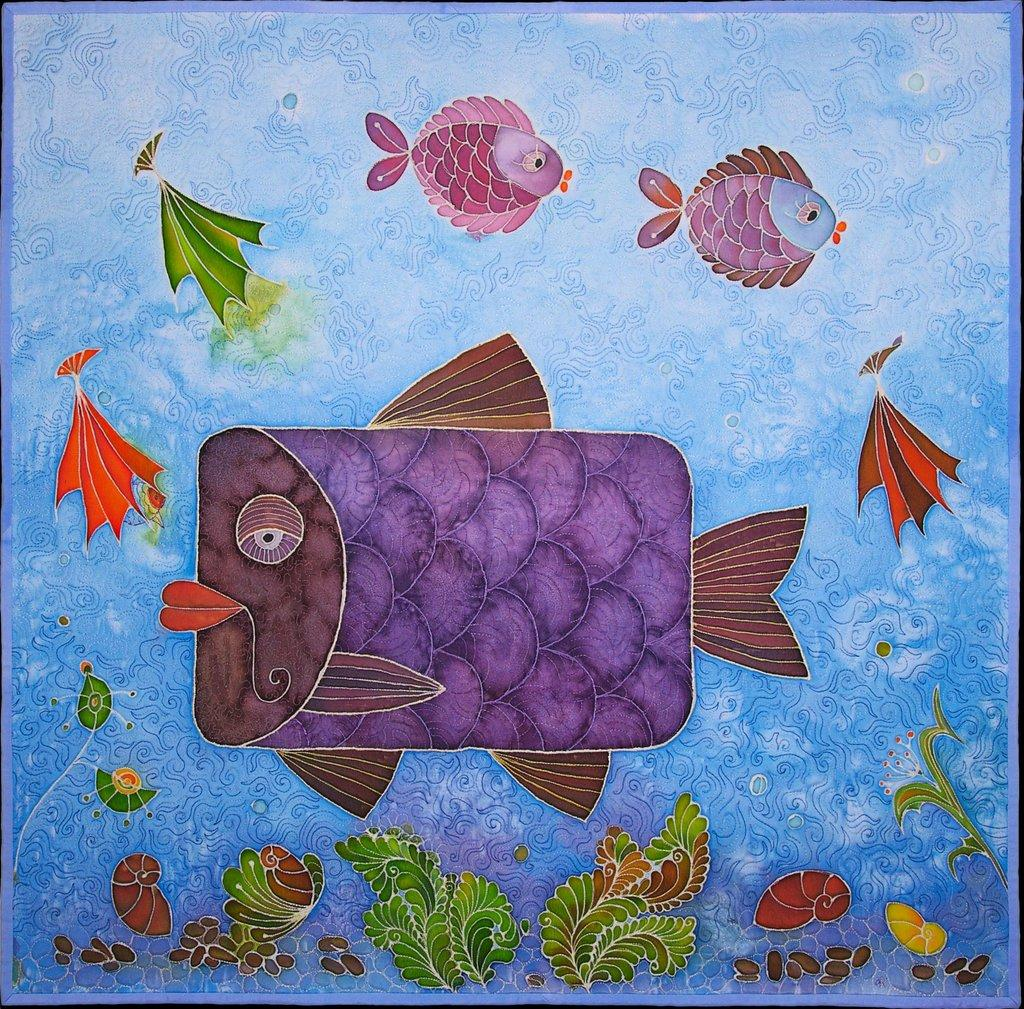What is the medium used for the poster in the image? The poster is painted. What types of animals are depicted in the paintings on the poster? There are paintings of fishes, tortoises, and snails on the poster. What other subjects are featured in the paintings on the poster? There are paintings of plants on the poster. What is the setting or environment depicted in the paintings on the poster? There is water depicted in the paintings on the poster. What type of current is flowing through the water in the image? There is no indication of a current in the water depicted in the paintings on the poster. How much does the dime cost in the image? There is no dime present in the image. 